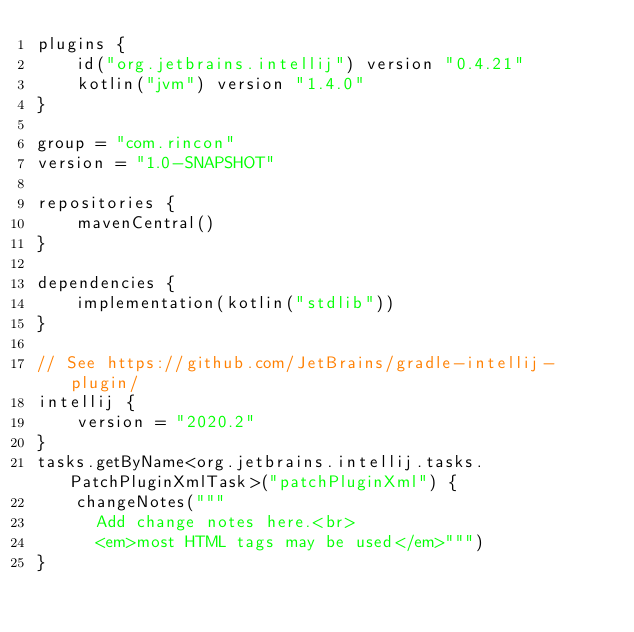<code> <loc_0><loc_0><loc_500><loc_500><_Kotlin_>plugins {
    id("org.jetbrains.intellij") version "0.4.21"
    kotlin("jvm") version "1.4.0"
}

group = "com.rincon"
version = "1.0-SNAPSHOT"

repositories {
    mavenCentral()
}

dependencies {
    implementation(kotlin("stdlib"))
}

// See https://github.com/JetBrains/gradle-intellij-plugin/
intellij {
    version = "2020.2"
}
tasks.getByName<org.jetbrains.intellij.tasks.PatchPluginXmlTask>("patchPluginXml") {
    changeNotes("""
      Add change notes here.<br>
      <em>most HTML tags may be used</em>""")
}</code> 